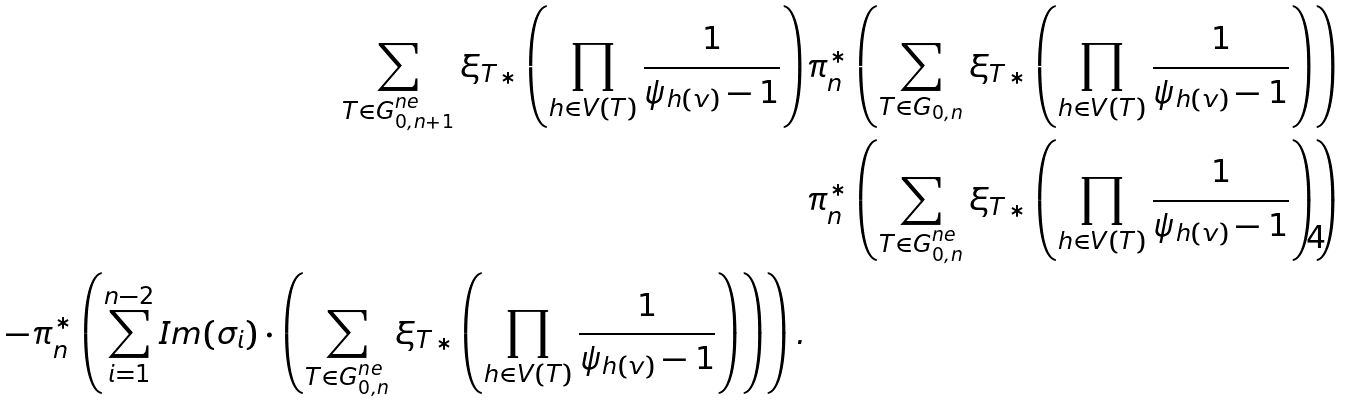Convert formula to latex. <formula><loc_0><loc_0><loc_500><loc_500>\sum _ { T \in G _ { 0 , n + 1 } ^ { n e } } { \xi _ { T } } _ { * } \left ( \prod _ { h \in V ( T ) } \frac { 1 } { \psi _ { h ( v ) } - 1 } \right ) & \pi _ { n } ^ { * } \left ( \sum _ { T \in G _ { 0 , n } } { \xi _ { T } } _ { * } \left ( \prod _ { h \in V ( T ) } \frac { 1 } { \psi _ { h ( v ) } - 1 } \right ) \right ) \\ & \pi _ { n } ^ { * } \left ( \sum _ { T \in G _ { 0 , n } ^ { n e } } { \xi _ { T } } _ { * } \left ( \prod _ { h \in V ( T ) } \frac { 1 } { \psi _ { h ( v ) } - 1 } \right ) \right ) \\ - \pi _ { n } ^ { * } \left ( \sum _ { i = 1 } ^ { n - 2 } I m ( \sigma _ { i } ) \cdot \left ( \sum _ { T \in G _ { 0 , n } ^ { n e } } { \xi _ { T } } _ { * } \left ( \prod _ { h \in V ( T ) } \frac { 1 } { \psi _ { h ( v ) } - 1 } \right ) \right ) \right ) .</formula> 